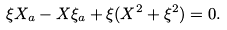<formula> <loc_0><loc_0><loc_500><loc_500>\xi X _ { a } - X { \xi } _ { a } + \xi ( X ^ { 2 } + { \xi } ^ { 2 } ) = 0 .</formula> 